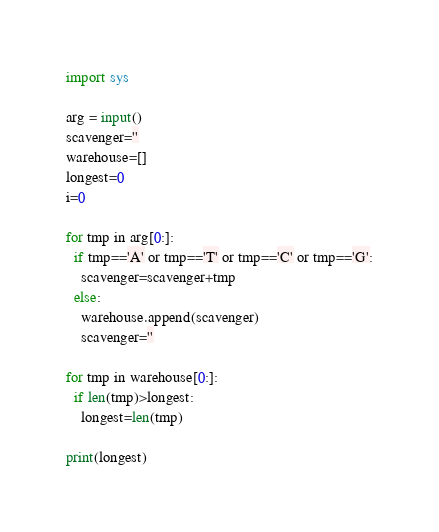Convert code to text. <code><loc_0><loc_0><loc_500><loc_500><_Python_>import sys

arg = input()
scavenger=''
warehouse=[]
longest=0
i=0

for tmp in arg[0:]:
  if tmp=='A' or tmp=='T' or tmp=='C' or tmp=='G':
    scavenger=scavenger+tmp
  else:
    warehouse.append(scavenger)
    scavenger=''

for tmp in warehouse[0:]:
  if len(tmp)>longest:
    longest=len(tmp)

print(longest)</code> 